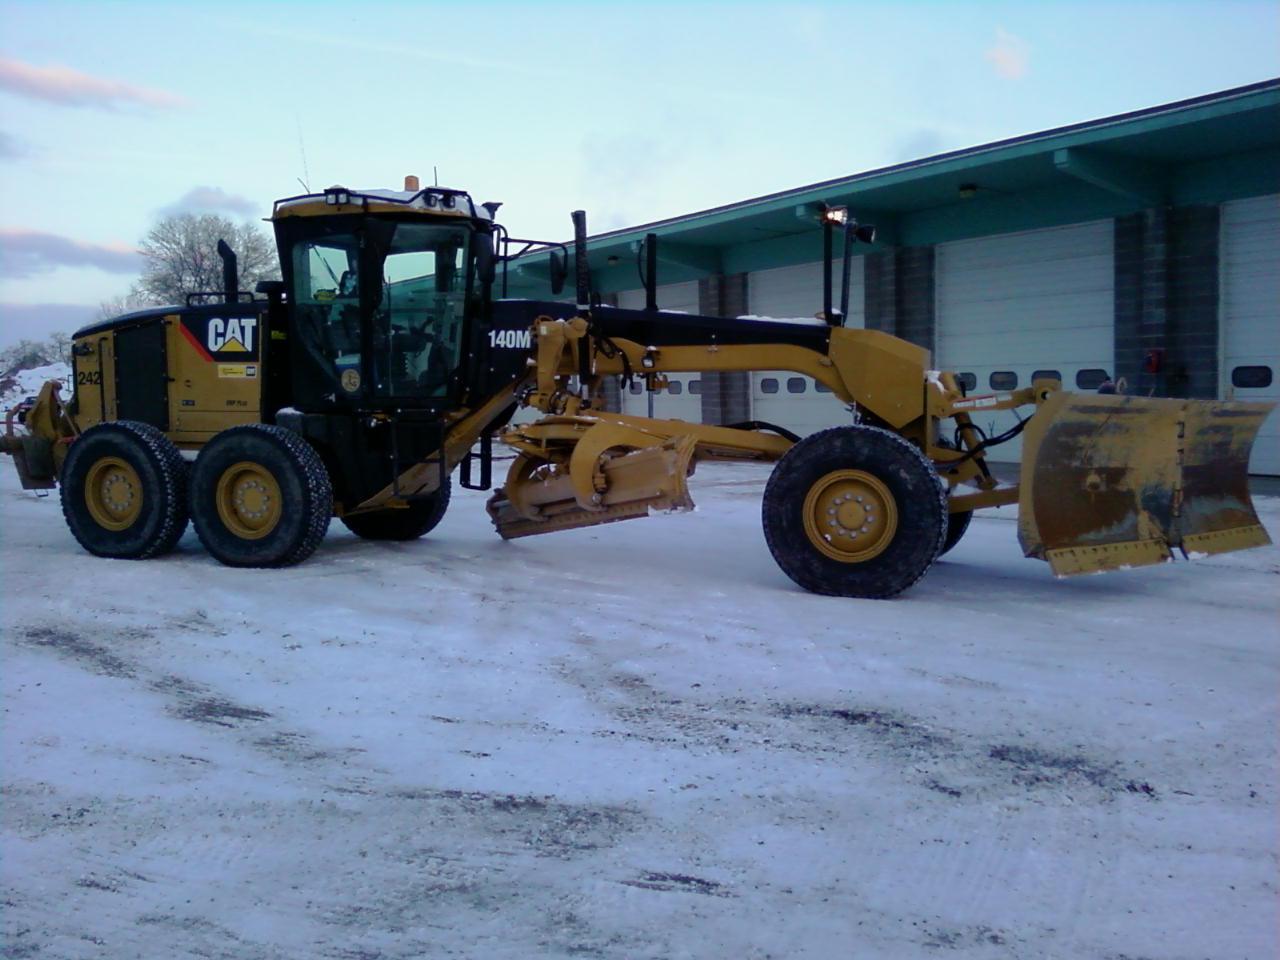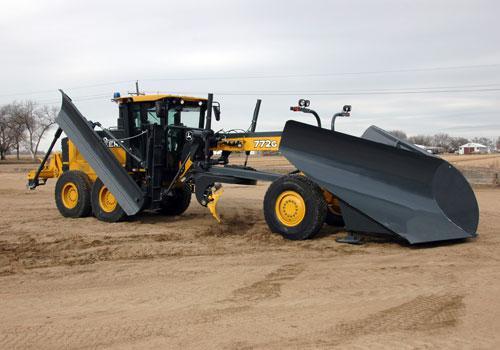The first image is the image on the left, the second image is the image on the right. Assess this claim about the two images: "The equipment in both images is yellow, but one is parked on a snowy surface, while the other is not.". Correct or not? Answer yes or no. Yes. The first image is the image on the left, the second image is the image on the right. Considering the images on both sides, is "The plow on the tractor on the right side is grey." valid? Answer yes or no. Yes. 